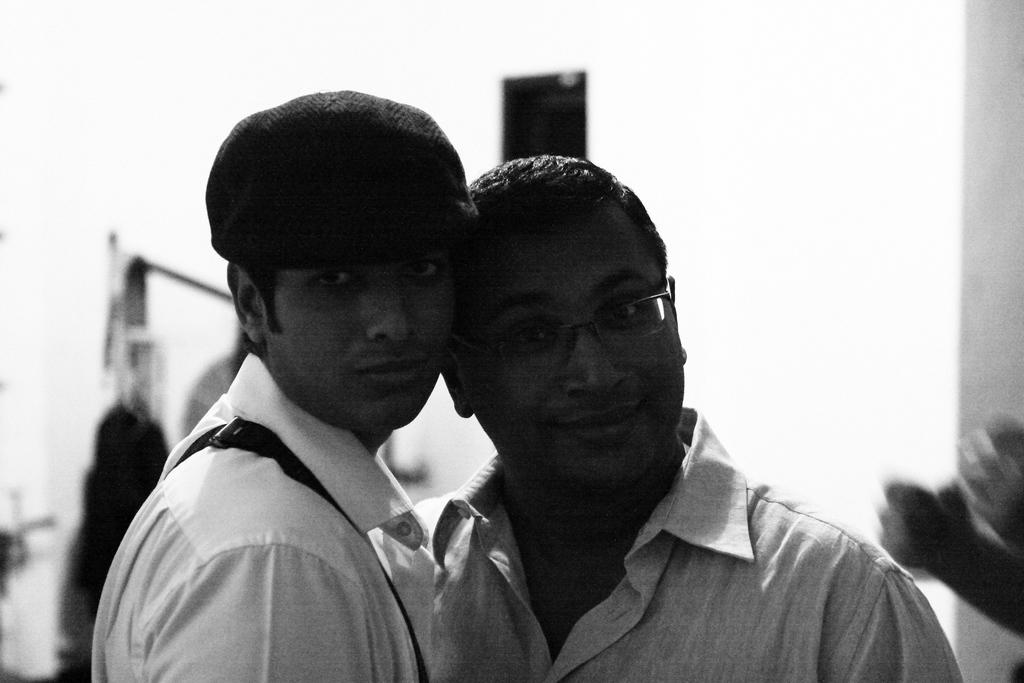How many people are in the image? There are two men in the image. What are the men wearing? The men are wearing shirts. What type of tooth is visible in the image? There is no tooth visible in the image; it features two men wearing shirts. 